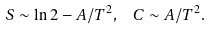Convert formula to latex. <formula><loc_0><loc_0><loc_500><loc_500>S \sim \ln 2 - A / T ^ { 2 } , \ \ C \sim A / T ^ { 2 } .</formula> 